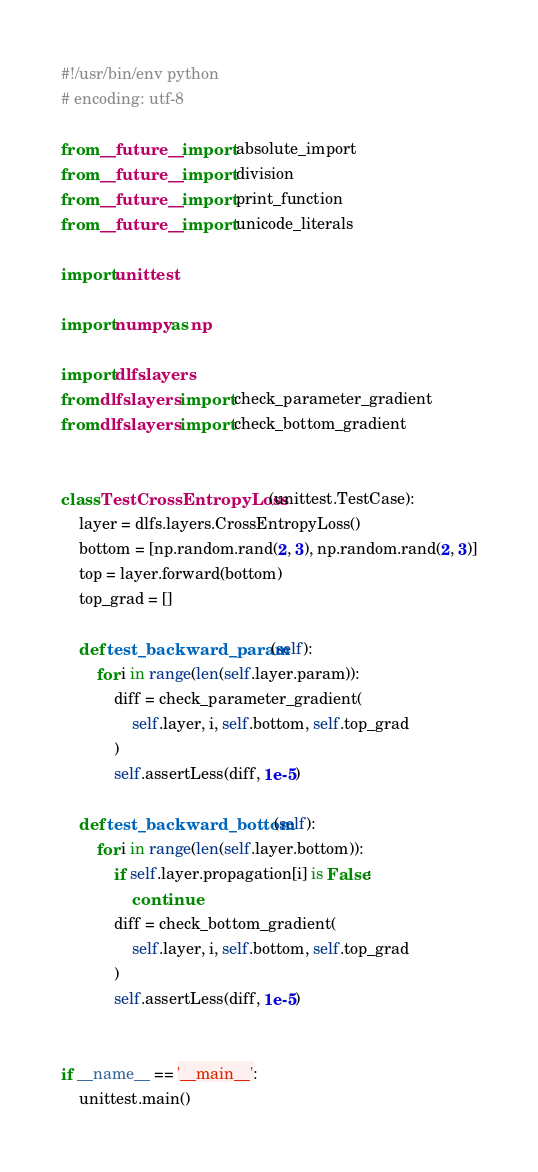Convert code to text. <code><loc_0><loc_0><loc_500><loc_500><_Python_>#!/usr/bin/env python
# encoding: utf-8

from __future__ import absolute_import
from __future__ import division
from __future__ import print_function
from __future__ import unicode_literals

import unittest

import numpy as np

import dlfs.layers
from dlfs.layers import check_parameter_gradient
from dlfs.layers import check_bottom_gradient


class TestCrossEntropyLoss(unittest.TestCase):
    layer = dlfs.layers.CrossEntropyLoss()
    bottom = [np.random.rand(2, 3), np.random.rand(2, 3)]
    top = layer.forward(bottom)
    top_grad = []

    def test_backward_param(self):
        for i in range(len(self.layer.param)):
            diff = check_parameter_gradient(
                self.layer, i, self.bottom, self.top_grad
            )
            self.assertLess(diff, 1e-5)

    def test_backward_bottom(self):
        for i in range(len(self.layer.bottom)):
            if self.layer.propagation[i] is False:
                continue
            diff = check_bottom_gradient(
                self.layer, i, self.bottom, self.top_grad
            )
            self.assertLess(diff, 1e-5)


if __name__ == '__main__':
    unittest.main()
</code> 